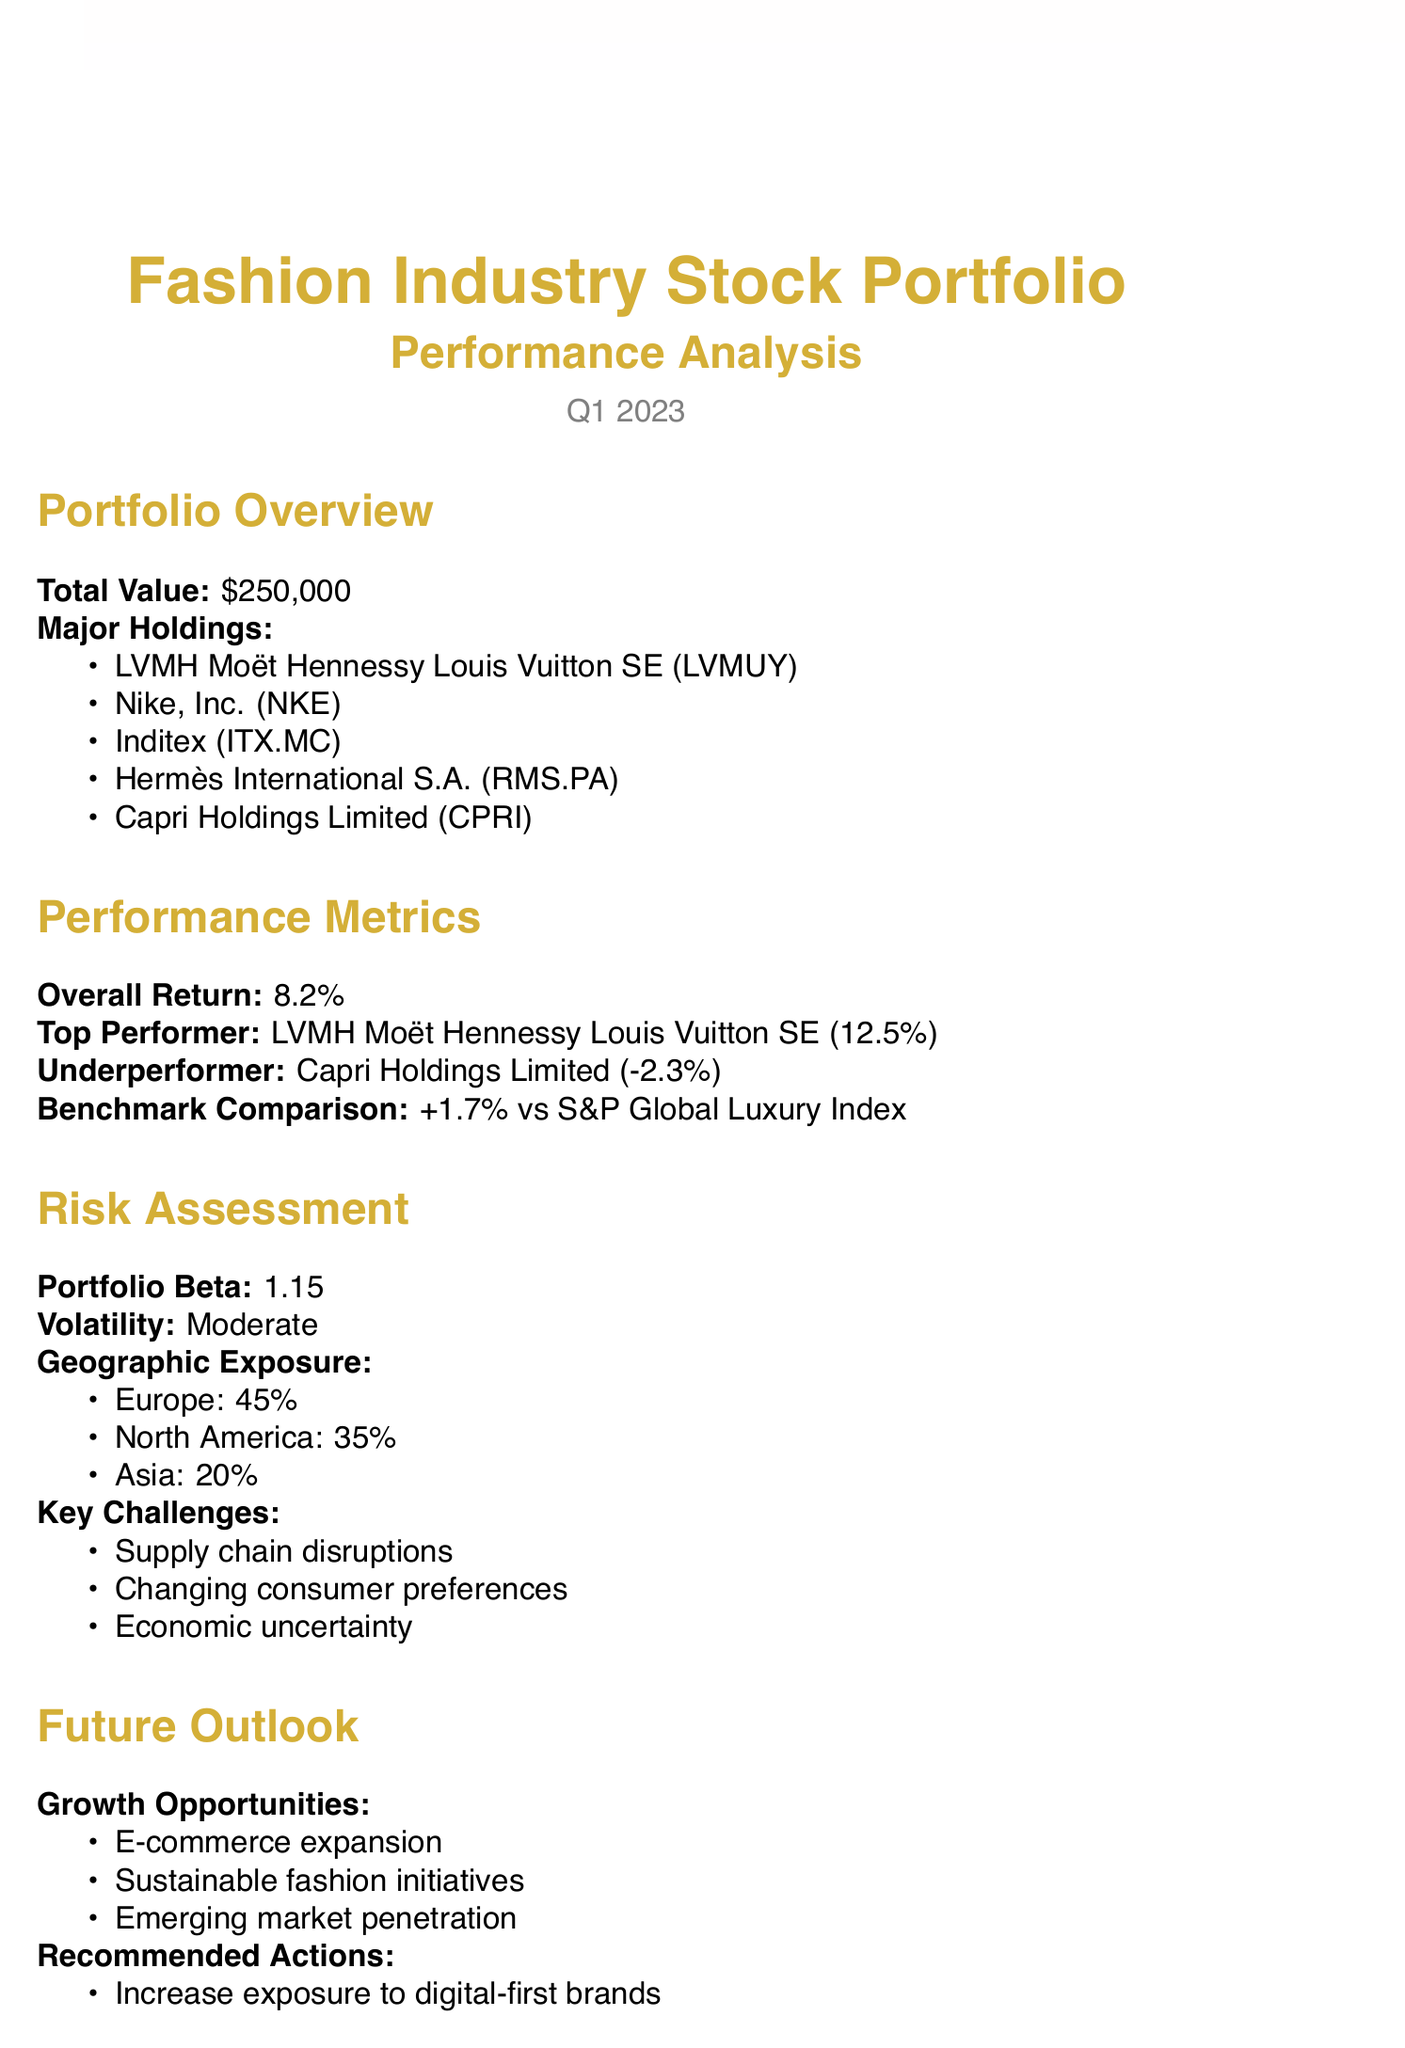what is the total value of the portfolio? The total value of the portfolio is stated in the overview section of the document.
Answer: $250,000 who is the top performer in the portfolio? The top performer is listed under the performance metrics section of the document.
Answer: LVMH Moët Hennessy Louis Vuitton SE what was the overall return of the portfolio? The overall return is provided in the performance metrics section of the document.
Answer: 8.2% what percentage of geographic exposure is allocated to Asia? The geographic exposure percentages are detailed in the risk assessment section.
Answer: 20% what is the portfolio beta? The portfolio beta is mentioned in the risk assessment section of the document.
Answer: 1.15 which stock is the underperformer in the portfolio? The underperformer is indicated in the performance metrics section of the document.
Answer: Capri Holdings Limited what are the recommended actions for the portfolio? The recommended actions are listed in the future outlook section of the document.
Answer: Increase exposure to digital-first brands what is one of the key challenges noted in the risk assessment? The key challenges are highlighted in the risk assessment section of the document.
Answer: Supply chain disruptions how does the portfolio performance compare to the S&P Global Luxury Index? The benchmark comparison is detailed under performance metrics.
Answer: +1.7% 